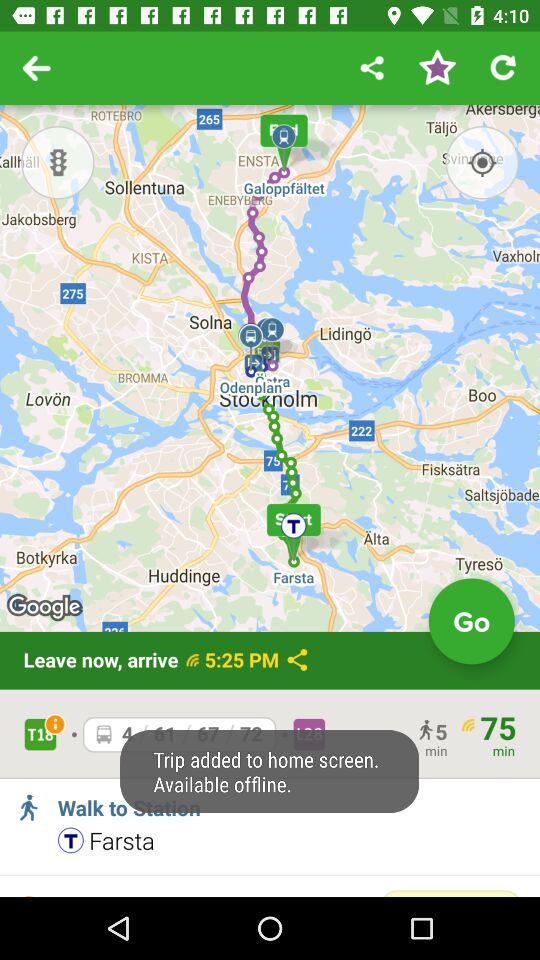What is the arrival time? The arrival time is 5:25 p.m. 